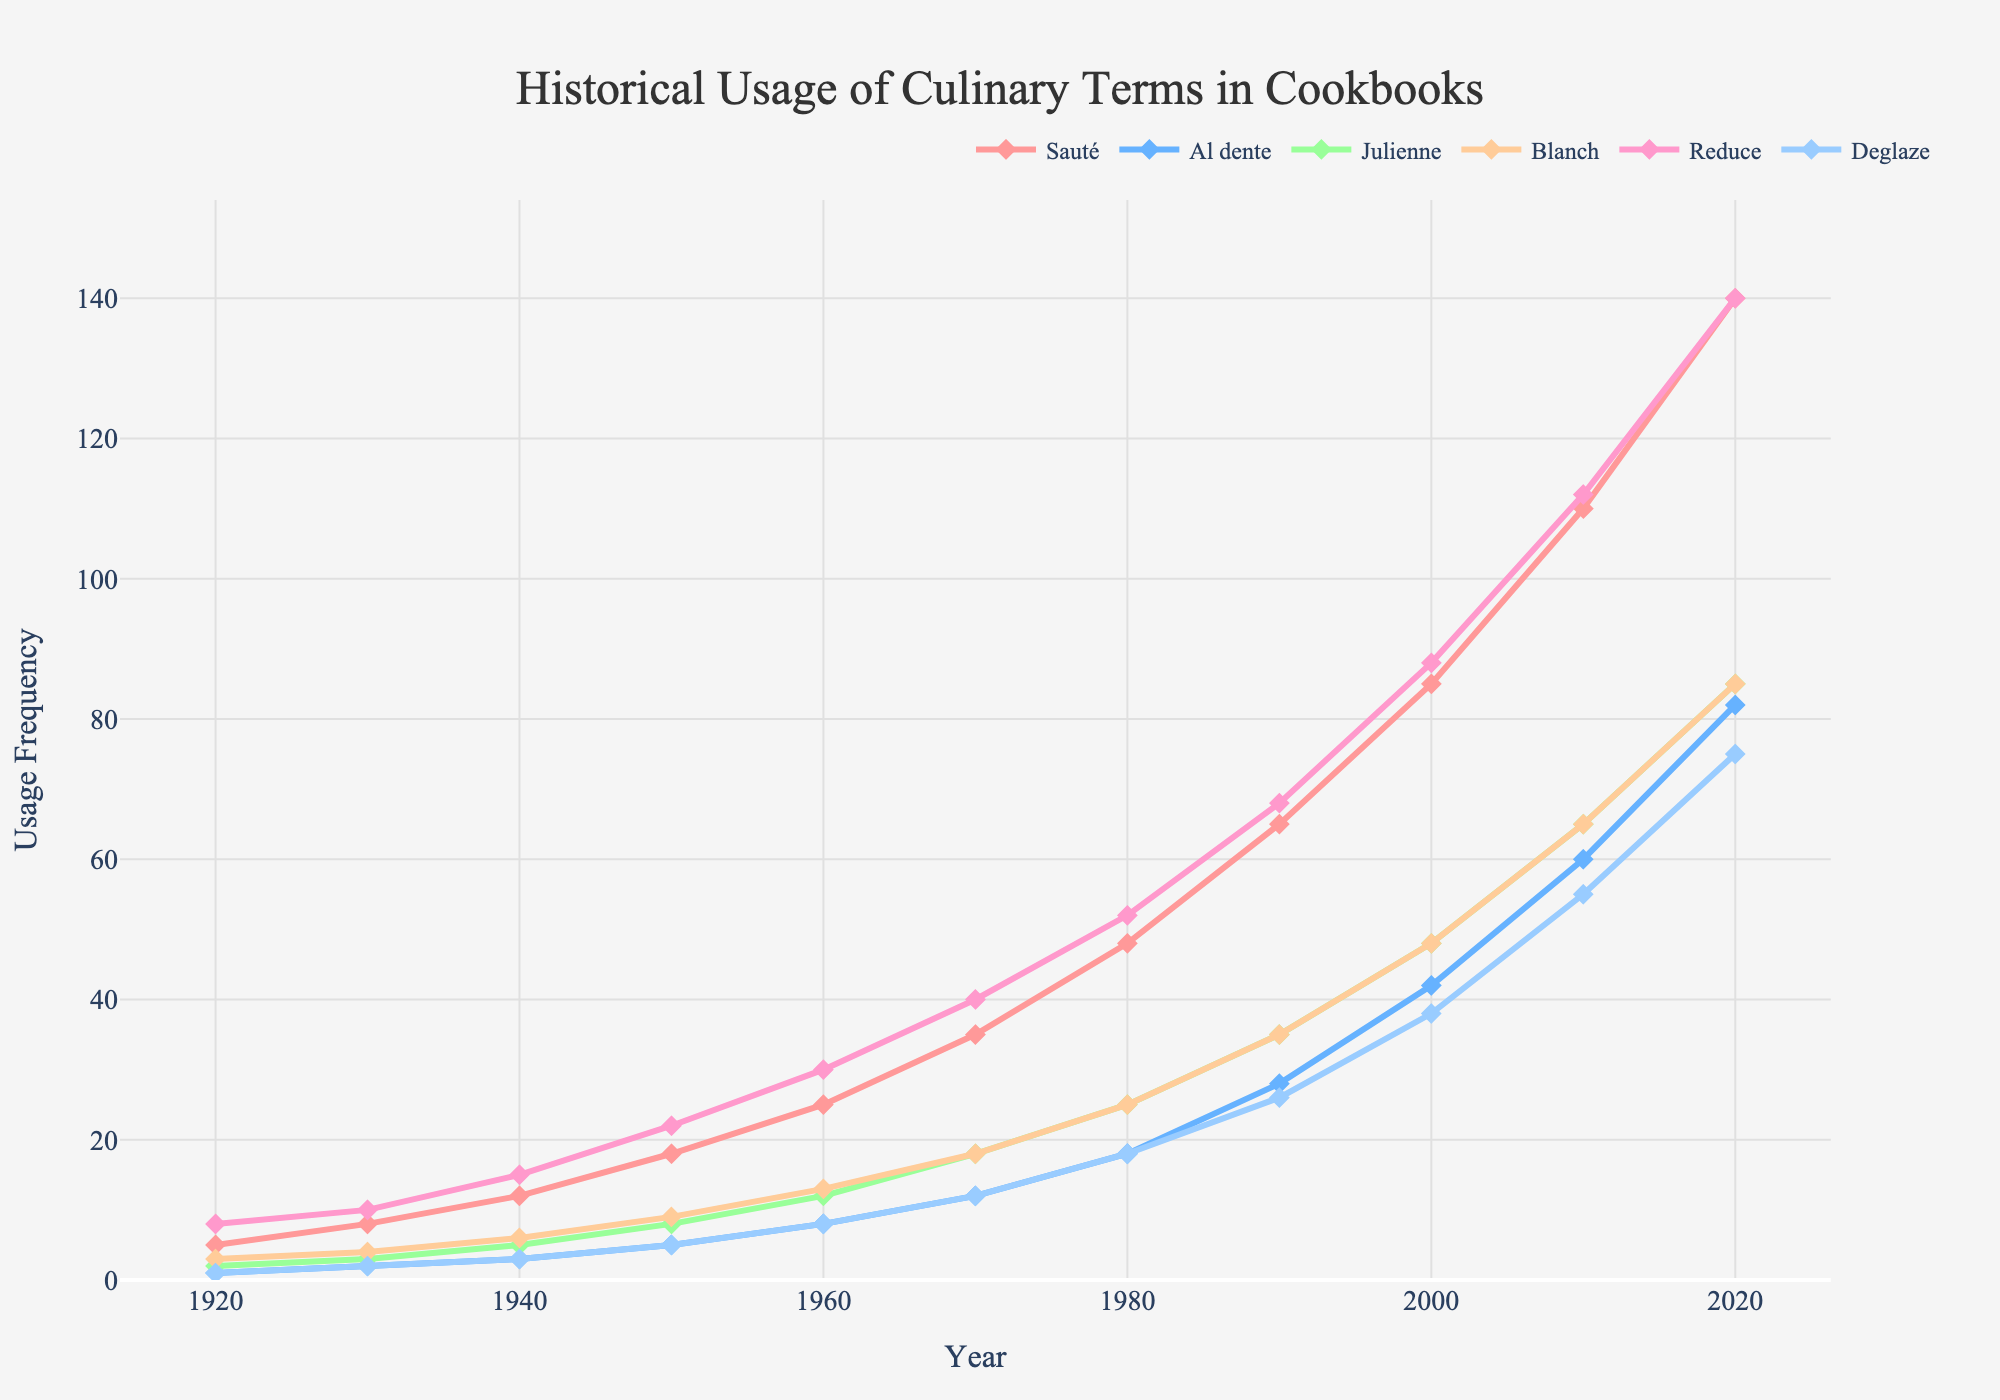Which term had the highest usage frequency in 2020? Look for the term that reaches the highest point on the line chart in the year 2020 and has the tallest marker at that year.
Answer: Sauté How did the usage of "Julienne" and "Blanch" compare in 1970? Compare the heights of the lines for "Julienne" and "Blanch" in the year 1970.
Answer: Julienne was higher What is the average usage frequency of the term "Reduce" across the entire century? Sum the frequency values of "Reduce" from 1920 to 2020 and then divide by the number of data points (11). Calculation: (8+10+15+22+30+40+52+68+88+112+140)/11 = 53.18
Answer: 53.18 Between 1950 and 2000, which term had the largest increase in usage? Calculate the differences in usage frequency for each term between 1950 and 2000, and identify the largest difference.
Answer: Sauté In which decade did the usage frequency of "Al dente" surpass 50? Look for the point where "Al dente" crosses the 50-marker on the y-axis and identify the corresponding decade.
Answer: 2010s Was there any term that consistently increased in usage frequency every decade? Verify if each term has a steady increase without any decrease from one decade to another.
Answer: Yes, Sauté How many terms had a usage frequency greater than 60 in 1990? Count the number of terms with markers above 60 on the y-axis for the year 1990.
Answer: Two Which term shows the steepest rise from 1980 to 1990? Compare the slopes of the lines for each term between 1980 and 1990. Look for the term with the steepest increase.
Answer: Sauté Did any term have a higher usage frequency in 1920 than "Sauté"? Look at the value of "Sauté" in 1920 and compare it with the other terms in the same year to see if any is higher.
Answer: No What was the usage frequency difference between "Deglaze" and "Blanch" in 2010? Subtract the frequency of "Blanch" from that of "Deglaze" in the year 2010. Calculation: 55 - 65 = -10
Answer: -10 